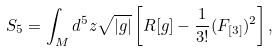<formula> <loc_0><loc_0><loc_500><loc_500>S _ { 5 } = \int _ { M } d ^ { 5 } z \sqrt { | g | } \left [ { R } [ g ] - \frac { 1 } { 3 ! } ( F _ { [ 3 ] } ) ^ { 2 } \right ] ,</formula> 